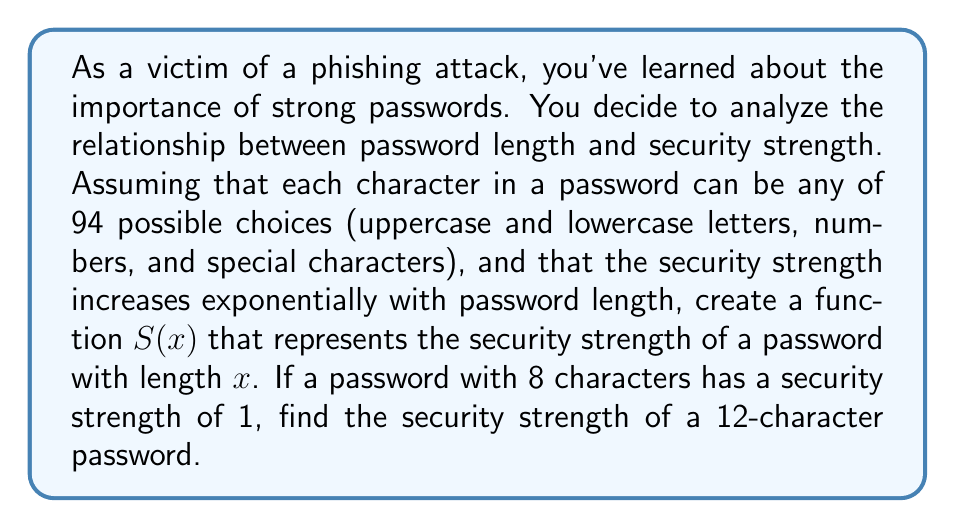What is the answer to this math problem? Let's approach this step-by-step:

1) We know that the security strength increases exponentially with password length. This suggests an exponential function of the form:

   $S(x) = a \cdot b^x$

   where $a$ is a constant and $b$ is the base of the exponential function.

2) We're given that there are 94 possible choices for each character. This means that for each additional character, the number of possible passwords is multiplied by 94. Therefore, $b = 94$.

3) Now our function looks like:

   $S(x) = a \cdot 94^x$

4) We're told that a password with 8 characters has a security strength of 1. We can use this to find $a$:

   $S(8) = 1 = a \cdot 94^8$
   $a = \frac{1}{94^8}$

5) Now we have our complete function:

   $S(x) = \frac{94^x}{94^8} = 94^{x-8}$

6) To find the security strength of a 12-character password, we simply plug in $x = 12$:

   $S(12) = 94^{12-8} = 94^4 = 78,074,896$

Thus, a 12-character password is 78,074,896 times stronger than an 8-character password.
Answer: The security strength of a 12-character password is $94^4 = 78,074,896$ times stronger than an 8-character password. 